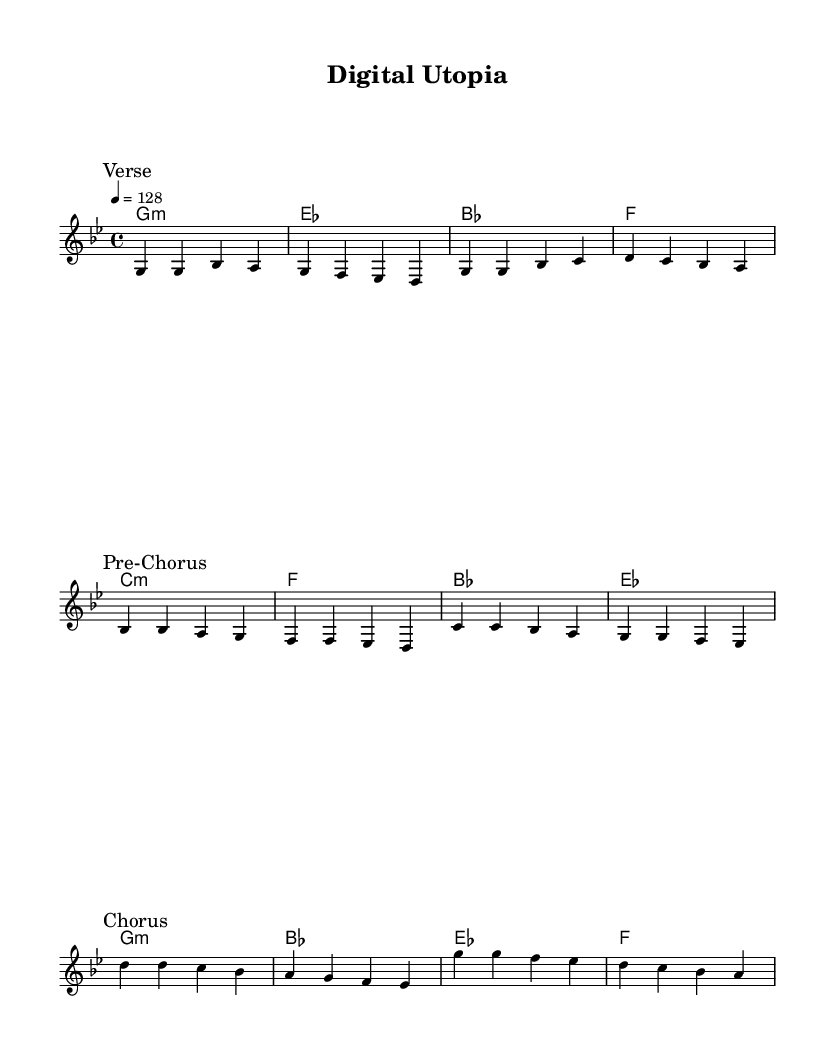What is the key signature of this music? The key signature of the piece is G minor, as indicated at the beginning of the score. G minor has two flats (B♭ and E♭).
Answer: G minor What is the time signature of this music? The time signature shown in the score is 4/4, meaning there are four beats per measure and the quarter note gets one beat. This is indicated near the beginning of the piece.
Answer: 4/4 What is the tempo marking of this music? The tempo marking is indicated as "4 = 128," meaning there are 128 beats per minute, and the quarter note is the note that receives a beat.
Answer: 128 How many measures are in the verse section? The verse section has four measures, as counted from the music where it ends before the break leading into the pre-chorus.
Answer: 4 What are the chords used in the chorus? The chords in the chorus are G minor, B♭, E♭, and F. These can be found in the chord mode section for the chorus part of the music.
Answer: G minor, B♭, E♭, F Which section immediately follows the verse? The section that immediately follows the verse is the pre-chorus, as indicated by the break in the music and the labeling of sections.
Answer: Pre-Chorus What is the melodic range of the chorus? The melodic range of the chorus spans from D to A, which can be observed by looking at the notes written in the chorus section.
Answer: D to A 